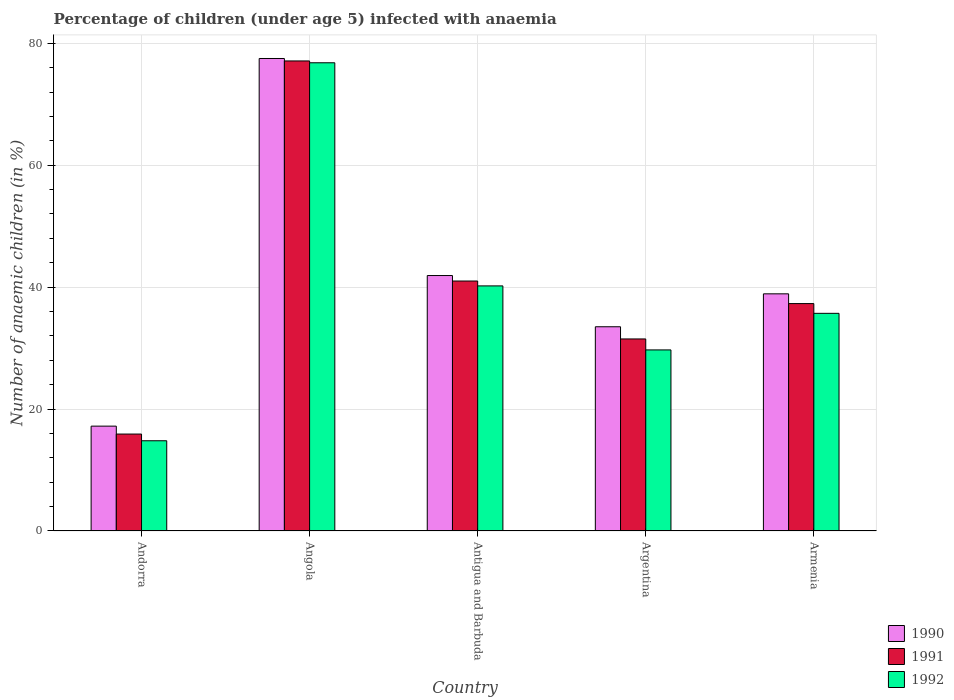How many different coloured bars are there?
Offer a very short reply. 3. How many bars are there on the 1st tick from the right?
Your answer should be very brief. 3. What is the label of the 4th group of bars from the left?
Offer a very short reply. Argentina. Across all countries, what is the maximum percentage of children infected with anaemia in in 1992?
Give a very brief answer. 76.8. In which country was the percentage of children infected with anaemia in in 1992 maximum?
Make the answer very short. Angola. In which country was the percentage of children infected with anaemia in in 1991 minimum?
Your answer should be very brief. Andorra. What is the total percentage of children infected with anaemia in in 1990 in the graph?
Make the answer very short. 209. What is the difference between the percentage of children infected with anaemia in in 1990 in Andorra and that in Antigua and Barbuda?
Keep it short and to the point. -24.7. What is the difference between the percentage of children infected with anaemia in in 1990 in Antigua and Barbuda and the percentage of children infected with anaemia in in 1991 in Argentina?
Provide a short and direct response. 10.4. What is the average percentage of children infected with anaemia in in 1991 per country?
Give a very brief answer. 40.56. What is the difference between the percentage of children infected with anaemia in of/in 1990 and percentage of children infected with anaemia in of/in 1992 in Armenia?
Make the answer very short. 3.2. In how many countries, is the percentage of children infected with anaemia in in 1991 greater than 40 %?
Your response must be concise. 2. What is the ratio of the percentage of children infected with anaemia in in 1992 in Angola to that in Antigua and Barbuda?
Your answer should be very brief. 1.91. What is the difference between the highest and the second highest percentage of children infected with anaemia in in 1992?
Your answer should be compact. 4.5. In how many countries, is the percentage of children infected with anaemia in in 1991 greater than the average percentage of children infected with anaemia in in 1991 taken over all countries?
Give a very brief answer. 2. What does the 3rd bar from the left in Argentina represents?
Provide a succinct answer. 1992. Is it the case that in every country, the sum of the percentage of children infected with anaemia in in 1990 and percentage of children infected with anaemia in in 1991 is greater than the percentage of children infected with anaemia in in 1992?
Keep it short and to the point. Yes. How many countries are there in the graph?
Your response must be concise. 5. Are the values on the major ticks of Y-axis written in scientific E-notation?
Make the answer very short. No. What is the title of the graph?
Keep it short and to the point. Percentage of children (under age 5) infected with anaemia. What is the label or title of the X-axis?
Offer a very short reply. Country. What is the label or title of the Y-axis?
Make the answer very short. Number of anaemic children (in %). What is the Number of anaemic children (in %) of 1990 in Andorra?
Offer a very short reply. 17.2. What is the Number of anaemic children (in %) in 1991 in Andorra?
Offer a very short reply. 15.9. What is the Number of anaemic children (in %) of 1992 in Andorra?
Ensure brevity in your answer.  14.8. What is the Number of anaemic children (in %) in 1990 in Angola?
Ensure brevity in your answer.  77.5. What is the Number of anaemic children (in %) in 1991 in Angola?
Offer a terse response. 77.1. What is the Number of anaemic children (in %) in 1992 in Angola?
Provide a succinct answer. 76.8. What is the Number of anaemic children (in %) of 1990 in Antigua and Barbuda?
Offer a terse response. 41.9. What is the Number of anaemic children (in %) of 1992 in Antigua and Barbuda?
Your answer should be very brief. 40.2. What is the Number of anaemic children (in %) of 1990 in Argentina?
Keep it short and to the point. 33.5. What is the Number of anaemic children (in %) in 1991 in Argentina?
Offer a very short reply. 31.5. What is the Number of anaemic children (in %) in 1992 in Argentina?
Your answer should be compact. 29.7. What is the Number of anaemic children (in %) in 1990 in Armenia?
Provide a succinct answer. 38.9. What is the Number of anaemic children (in %) of 1991 in Armenia?
Give a very brief answer. 37.3. What is the Number of anaemic children (in %) of 1992 in Armenia?
Provide a succinct answer. 35.7. Across all countries, what is the maximum Number of anaemic children (in %) of 1990?
Ensure brevity in your answer.  77.5. Across all countries, what is the maximum Number of anaemic children (in %) of 1991?
Your answer should be compact. 77.1. Across all countries, what is the maximum Number of anaemic children (in %) in 1992?
Keep it short and to the point. 76.8. Across all countries, what is the minimum Number of anaemic children (in %) of 1990?
Your answer should be compact. 17.2. Across all countries, what is the minimum Number of anaemic children (in %) in 1992?
Ensure brevity in your answer.  14.8. What is the total Number of anaemic children (in %) of 1990 in the graph?
Provide a succinct answer. 209. What is the total Number of anaemic children (in %) in 1991 in the graph?
Offer a very short reply. 202.8. What is the total Number of anaemic children (in %) of 1992 in the graph?
Offer a very short reply. 197.2. What is the difference between the Number of anaemic children (in %) in 1990 in Andorra and that in Angola?
Offer a terse response. -60.3. What is the difference between the Number of anaemic children (in %) in 1991 in Andorra and that in Angola?
Offer a very short reply. -61.2. What is the difference between the Number of anaemic children (in %) in 1992 in Andorra and that in Angola?
Give a very brief answer. -62. What is the difference between the Number of anaemic children (in %) of 1990 in Andorra and that in Antigua and Barbuda?
Your answer should be very brief. -24.7. What is the difference between the Number of anaemic children (in %) in 1991 in Andorra and that in Antigua and Barbuda?
Make the answer very short. -25.1. What is the difference between the Number of anaemic children (in %) of 1992 in Andorra and that in Antigua and Barbuda?
Give a very brief answer. -25.4. What is the difference between the Number of anaemic children (in %) in 1990 in Andorra and that in Argentina?
Make the answer very short. -16.3. What is the difference between the Number of anaemic children (in %) in 1991 in Andorra and that in Argentina?
Ensure brevity in your answer.  -15.6. What is the difference between the Number of anaemic children (in %) of 1992 in Andorra and that in Argentina?
Provide a short and direct response. -14.9. What is the difference between the Number of anaemic children (in %) in 1990 in Andorra and that in Armenia?
Your answer should be very brief. -21.7. What is the difference between the Number of anaemic children (in %) of 1991 in Andorra and that in Armenia?
Your response must be concise. -21.4. What is the difference between the Number of anaemic children (in %) of 1992 in Andorra and that in Armenia?
Your answer should be very brief. -20.9. What is the difference between the Number of anaemic children (in %) of 1990 in Angola and that in Antigua and Barbuda?
Make the answer very short. 35.6. What is the difference between the Number of anaemic children (in %) of 1991 in Angola and that in Antigua and Barbuda?
Your answer should be very brief. 36.1. What is the difference between the Number of anaemic children (in %) in 1992 in Angola and that in Antigua and Barbuda?
Ensure brevity in your answer.  36.6. What is the difference between the Number of anaemic children (in %) of 1991 in Angola and that in Argentina?
Provide a succinct answer. 45.6. What is the difference between the Number of anaemic children (in %) of 1992 in Angola and that in Argentina?
Offer a terse response. 47.1. What is the difference between the Number of anaemic children (in %) of 1990 in Angola and that in Armenia?
Offer a terse response. 38.6. What is the difference between the Number of anaemic children (in %) in 1991 in Angola and that in Armenia?
Your answer should be very brief. 39.8. What is the difference between the Number of anaemic children (in %) in 1992 in Angola and that in Armenia?
Your response must be concise. 41.1. What is the difference between the Number of anaemic children (in %) of 1990 in Antigua and Barbuda and that in Argentina?
Keep it short and to the point. 8.4. What is the difference between the Number of anaemic children (in %) in 1992 in Antigua and Barbuda and that in Argentina?
Give a very brief answer. 10.5. What is the difference between the Number of anaemic children (in %) of 1990 in Antigua and Barbuda and that in Armenia?
Provide a succinct answer. 3. What is the difference between the Number of anaemic children (in %) of 1991 in Antigua and Barbuda and that in Armenia?
Make the answer very short. 3.7. What is the difference between the Number of anaemic children (in %) in 1990 in Argentina and that in Armenia?
Offer a very short reply. -5.4. What is the difference between the Number of anaemic children (in %) of 1991 in Argentina and that in Armenia?
Ensure brevity in your answer.  -5.8. What is the difference between the Number of anaemic children (in %) of 1992 in Argentina and that in Armenia?
Provide a succinct answer. -6. What is the difference between the Number of anaemic children (in %) of 1990 in Andorra and the Number of anaemic children (in %) of 1991 in Angola?
Make the answer very short. -59.9. What is the difference between the Number of anaemic children (in %) of 1990 in Andorra and the Number of anaemic children (in %) of 1992 in Angola?
Your answer should be very brief. -59.6. What is the difference between the Number of anaemic children (in %) of 1991 in Andorra and the Number of anaemic children (in %) of 1992 in Angola?
Make the answer very short. -60.9. What is the difference between the Number of anaemic children (in %) of 1990 in Andorra and the Number of anaemic children (in %) of 1991 in Antigua and Barbuda?
Ensure brevity in your answer.  -23.8. What is the difference between the Number of anaemic children (in %) of 1990 in Andorra and the Number of anaemic children (in %) of 1992 in Antigua and Barbuda?
Give a very brief answer. -23. What is the difference between the Number of anaemic children (in %) of 1991 in Andorra and the Number of anaemic children (in %) of 1992 in Antigua and Barbuda?
Make the answer very short. -24.3. What is the difference between the Number of anaemic children (in %) in 1990 in Andorra and the Number of anaemic children (in %) in 1991 in Argentina?
Your response must be concise. -14.3. What is the difference between the Number of anaemic children (in %) in 1990 in Andorra and the Number of anaemic children (in %) in 1992 in Argentina?
Offer a very short reply. -12.5. What is the difference between the Number of anaemic children (in %) of 1991 in Andorra and the Number of anaemic children (in %) of 1992 in Argentina?
Make the answer very short. -13.8. What is the difference between the Number of anaemic children (in %) in 1990 in Andorra and the Number of anaemic children (in %) in 1991 in Armenia?
Provide a succinct answer. -20.1. What is the difference between the Number of anaemic children (in %) in 1990 in Andorra and the Number of anaemic children (in %) in 1992 in Armenia?
Offer a terse response. -18.5. What is the difference between the Number of anaemic children (in %) of 1991 in Andorra and the Number of anaemic children (in %) of 1992 in Armenia?
Your answer should be compact. -19.8. What is the difference between the Number of anaemic children (in %) of 1990 in Angola and the Number of anaemic children (in %) of 1991 in Antigua and Barbuda?
Provide a short and direct response. 36.5. What is the difference between the Number of anaemic children (in %) of 1990 in Angola and the Number of anaemic children (in %) of 1992 in Antigua and Barbuda?
Give a very brief answer. 37.3. What is the difference between the Number of anaemic children (in %) in 1991 in Angola and the Number of anaemic children (in %) in 1992 in Antigua and Barbuda?
Provide a short and direct response. 36.9. What is the difference between the Number of anaemic children (in %) of 1990 in Angola and the Number of anaemic children (in %) of 1991 in Argentina?
Make the answer very short. 46. What is the difference between the Number of anaemic children (in %) in 1990 in Angola and the Number of anaemic children (in %) in 1992 in Argentina?
Ensure brevity in your answer.  47.8. What is the difference between the Number of anaemic children (in %) in 1991 in Angola and the Number of anaemic children (in %) in 1992 in Argentina?
Ensure brevity in your answer.  47.4. What is the difference between the Number of anaemic children (in %) of 1990 in Angola and the Number of anaemic children (in %) of 1991 in Armenia?
Your response must be concise. 40.2. What is the difference between the Number of anaemic children (in %) in 1990 in Angola and the Number of anaemic children (in %) in 1992 in Armenia?
Your response must be concise. 41.8. What is the difference between the Number of anaemic children (in %) in 1991 in Angola and the Number of anaemic children (in %) in 1992 in Armenia?
Give a very brief answer. 41.4. What is the difference between the Number of anaemic children (in %) of 1991 in Antigua and Barbuda and the Number of anaemic children (in %) of 1992 in Argentina?
Offer a terse response. 11.3. What is the difference between the Number of anaemic children (in %) of 1990 in Antigua and Barbuda and the Number of anaemic children (in %) of 1991 in Armenia?
Offer a very short reply. 4.6. What is the difference between the Number of anaemic children (in %) of 1990 in Antigua and Barbuda and the Number of anaemic children (in %) of 1992 in Armenia?
Your answer should be very brief. 6.2. What is the difference between the Number of anaemic children (in %) of 1991 in Argentina and the Number of anaemic children (in %) of 1992 in Armenia?
Provide a short and direct response. -4.2. What is the average Number of anaemic children (in %) in 1990 per country?
Ensure brevity in your answer.  41.8. What is the average Number of anaemic children (in %) in 1991 per country?
Ensure brevity in your answer.  40.56. What is the average Number of anaemic children (in %) in 1992 per country?
Your answer should be very brief. 39.44. What is the difference between the Number of anaemic children (in %) in 1990 and Number of anaemic children (in %) in 1991 in Andorra?
Ensure brevity in your answer.  1.3. What is the difference between the Number of anaemic children (in %) of 1991 and Number of anaemic children (in %) of 1992 in Andorra?
Your answer should be compact. 1.1. What is the difference between the Number of anaemic children (in %) of 1990 and Number of anaemic children (in %) of 1991 in Angola?
Give a very brief answer. 0.4. What is the difference between the Number of anaemic children (in %) in 1990 and Number of anaemic children (in %) in 1992 in Angola?
Your answer should be compact. 0.7. What is the difference between the Number of anaemic children (in %) of 1991 and Number of anaemic children (in %) of 1992 in Angola?
Give a very brief answer. 0.3. What is the difference between the Number of anaemic children (in %) in 1990 and Number of anaemic children (in %) in 1991 in Antigua and Barbuda?
Offer a very short reply. 0.9. What is the difference between the Number of anaemic children (in %) of 1990 and Number of anaemic children (in %) of 1992 in Antigua and Barbuda?
Provide a short and direct response. 1.7. What is the difference between the Number of anaemic children (in %) of 1990 and Number of anaemic children (in %) of 1992 in Argentina?
Give a very brief answer. 3.8. What is the difference between the Number of anaemic children (in %) in 1990 and Number of anaemic children (in %) in 1991 in Armenia?
Offer a very short reply. 1.6. What is the difference between the Number of anaemic children (in %) of 1990 and Number of anaemic children (in %) of 1992 in Armenia?
Offer a terse response. 3.2. What is the difference between the Number of anaemic children (in %) of 1991 and Number of anaemic children (in %) of 1992 in Armenia?
Provide a short and direct response. 1.6. What is the ratio of the Number of anaemic children (in %) of 1990 in Andorra to that in Angola?
Offer a very short reply. 0.22. What is the ratio of the Number of anaemic children (in %) in 1991 in Andorra to that in Angola?
Your response must be concise. 0.21. What is the ratio of the Number of anaemic children (in %) in 1992 in Andorra to that in Angola?
Give a very brief answer. 0.19. What is the ratio of the Number of anaemic children (in %) in 1990 in Andorra to that in Antigua and Barbuda?
Provide a short and direct response. 0.41. What is the ratio of the Number of anaemic children (in %) in 1991 in Andorra to that in Antigua and Barbuda?
Your answer should be very brief. 0.39. What is the ratio of the Number of anaemic children (in %) of 1992 in Andorra to that in Antigua and Barbuda?
Offer a very short reply. 0.37. What is the ratio of the Number of anaemic children (in %) in 1990 in Andorra to that in Argentina?
Give a very brief answer. 0.51. What is the ratio of the Number of anaemic children (in %) in 1991 in Andorra to that in Argentina?
Ensure brevity in your answer.  0.5. What is the ratio of the Number of anaemic children (in %) in 1992 in Andorra to that in Argentina?
Your answer should be very brief. 0.5. What is the ratio of the Number of anaemic children (in %) in 1990 in Andorra to that in Armenia?
Offer a very short reply. 0.44. What is the ratio of the Number of anaemic children (in %) in 1991 in Andorra to that in Armenia?
Ensure brevity in your answer.  0.43. What is the ratio of the Number of anaemic children (in %) in 1992 in Andorra to that in Armenia?
Your response must be concise. 0.41. What is the ratio of the Number of anaemic children (in %) in 1990 in Angola to that in Antigua and Barbuda?
Give a very brief answer. 1.85. What is the ratio of the Number of anaemic children (in %) of 1991 in Angola to that in Antigua and Barbuda?
Provide a short and direct response. 1.88. What is the ratio of the Number of anaemic children (in %) of 1992 in Angola to that in Antigua and Barbuda?
Provide a succinct answer. 1.91. What is the ratio of the Number of anaemic children (in %) of 1990 in Angola to that in Argentina?
Provide a short and direct response. 2.31. What is the ratio of the Number of anaemic children (in %) in 1991 in Angola to that in Argentina?
Your answer should be very brief. 2.45. What is the ratio of the Number of anaemic children (in %) of 1992 in Angola to that in Argentina?
Give a very brief answer. 2.59. What is the ratio of the Number of anaemic children (in %) of 1990 in Angola to that in Armenia?
Give a very brief answer. 1.99. What is the ratio of the Number of anaemic children (in %) of 1991 in Angola to that in Armenia?
Offer a very short reply. 2.07. What is the ratio of the Number of anaemic children (in %) of 1992 in Angola to that in Armenia?
Offer a very short reply. 2.15. What is the ratio of the Number of anaemic children (in %) of 1990 in Antigua and Barbuda to that in Argentina?
Ensure brevity in your answer.  1.25. What is the ratio of the Number of anaemic children (in %) in 1991 in Antigua and Barbuda to that in Argentina?
Your answer should be very brief. 1.3. What is the ratio of the Number of anaemic children (in %) of 1992 in Antigua and Barbuda to that in Argentina?
Your answer should be very brief. 1.35. What is the ratio of the Number of anaemic children (in %) of 1990 in Antigua and Barbuda to that in Armenia?
Keep it short and to the point. 1.08. What is the ratio of the Number of anaemic children (in %) in 1991 in Antigua and Barbuda to that in Armenia?
Your answer should be very brief. 1.1. What is the ratio of the Number of anaemic children (in %) in 1992 in Antigua and Barbuda to that in Armenia?
Ensure brevity in your answer.  1.13. What is the ratio of the Number of anaemic children (in %) of 1990 in Argentina to that in Armenia?
Provide a succinct answer. 0.86. What is the ratio of the Number of anaemic children (in %) of 1991 in Argentina to that in Armenia?
Offer a terse response. 0.84. What is the ratio of the Number of anaemic children (in %) of 1992 in Argentina to that in Armenia?
Give a very brief answer. 0.83. What is the difference between the highest and the second highest Number of anaemic children (in %) in 1990?
Offer a very short reply. 35.6. What is the difference between the highest and the second highest Number of anaemic children (in %) in 1991?
Your answer should be very brief. 36.1. What is the difference between the highest and the second highest Number of anaemic children (in %) in 1992?
Provide a succinct answer. 36.6. What is the difference between the highest and the lowest Number of anaemic children (in %) of 1990?
Your answer should be compact. 60.3. What is the difference between the highest and the lowest Number of anaemic children (in %) of 1991?
Your answer should be very brief. 61.2. What is the difference between the highest and the lowest Number of anaemic children (in %) in 1992?
Your answer should be compact. 62. 